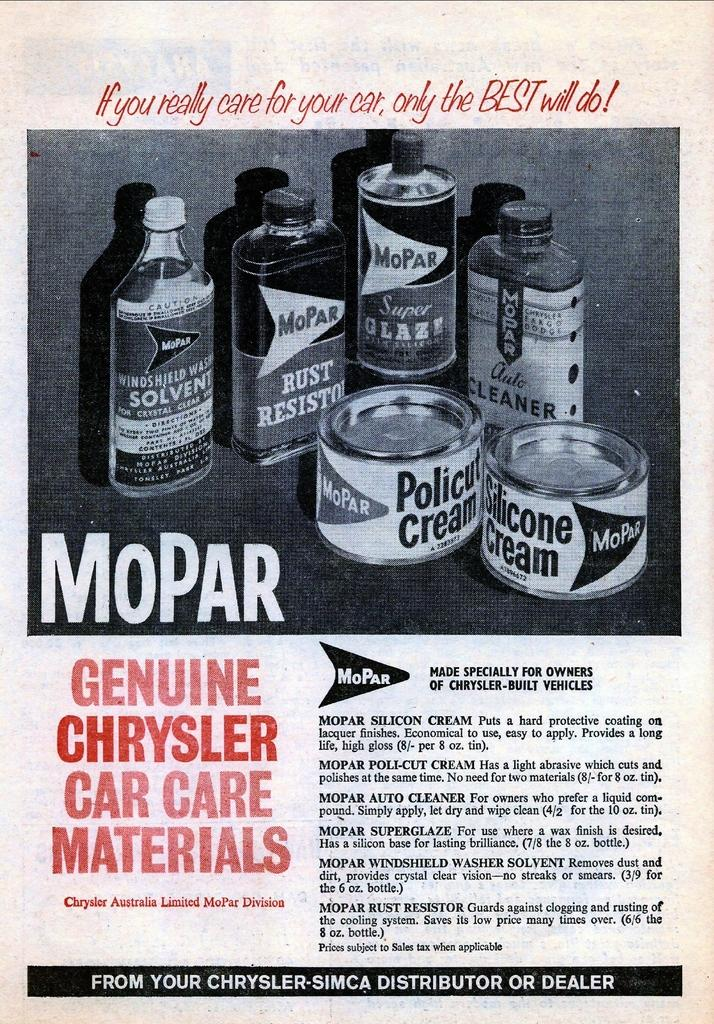Provide a one-sentence caption for the provided image. An old advertisement hawks various products from the Mopar line. 